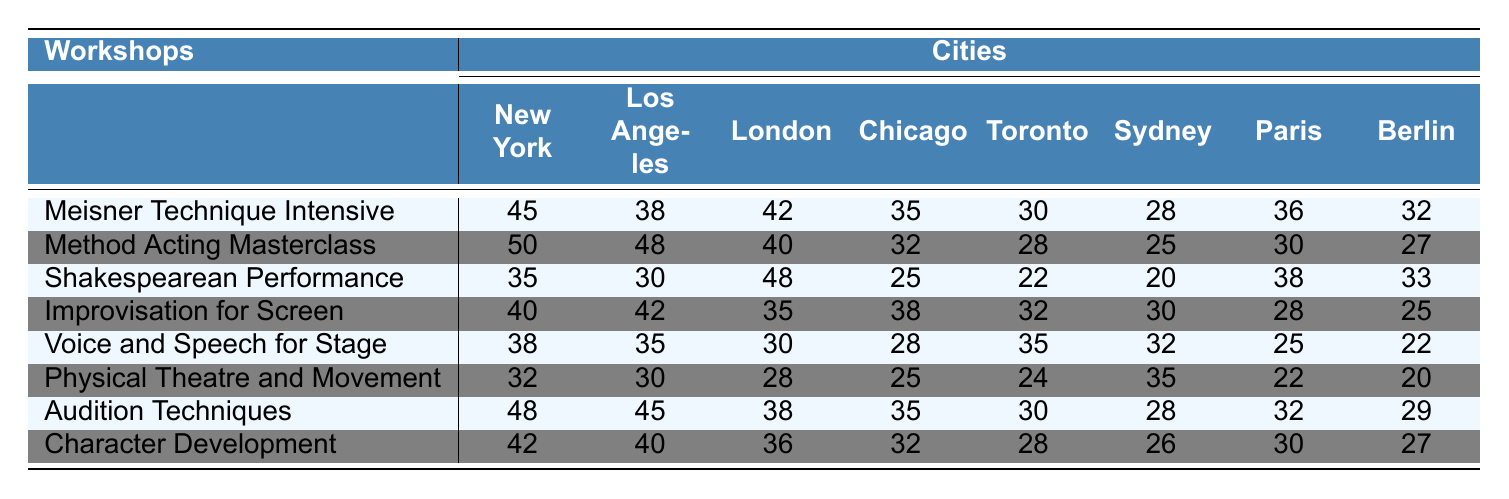What is the highest attendance recorded for the "Method Acting Masterclass"? The table shows the attendance for the "Method Acting Masterclass" across different cities. The highest figure is 50, which is in New York.
Answer: 50 Which city had the lowest attendance for the "Voice and Speech for Stage"? Looking at the "Voice and Speech for Stage" row, the lowest figure is 22, which appears to be in Berlin.
Answer: 22 What is the average attendance for the "Improvisation for Screen" workshop? To find the average, sum the attendance values: (40 + 42 + 35 + 38 + 32 + 30 + 28 + 25) = 330. There are 8 cities, so the average is 330/8 = 41.25.
Answer: 41.25 In which workshop did Toronto have the highest attendance? By reviewing the attendance values for Toronto, the highest is 35, which is for "Voice and Speech for Stage".
Answer: Voice and Speech for Stage Is the attendance for "Shakespearean Performance" in London higher than in New York? London has an attendance of 48 for "Shakespearean Performance", while New York has 35. Since 48 > 35, the attendance in London is higher.
Answer: Yes What is the total attendance across all workshops in Sydney? Adding the attendance figures for Sydney: (28 + 25 + 20 + 30 + 32 + 35 + 28 + 26) = 224 gives a total of 224 for all workshops.
Answer: 224 Which workshop had the second-highest total attendance when summing all cities? Summing attendance for each workshop: Meisner Technique Intensive (45+38+42+35+30+28+36+32 = 286), Method Acting Masterclass (50+48+40+32+28+25+30+27 = 280), Shakespearean Performance (35+30+48+25+22+20+38+33 = 251), Improvisation for Screen (40+42+35+38+32+30+28+25 = 300), Voice and Speech for Stage (38+35+30+28+35+32+25+22 =  315), Physical Theatre and Movement (32+30+28+25+24+35+22+20 =  246), Audition Techniques (48+45+38+35+30+28+32+29 =  305), Character Development (42+40+36+32+28+26+30+27 =  291). The second-highest is Audition Techniques with a total of 305.
Answer: Audition Techniques Is the attendance for "Character Development" higher in Chicago than in Toronto? The attendance for "Character Development" is 32 in Chicago and 28 in Toronto. Since 32 > 28, Chicago has higher attendance.
Answer: Yes 